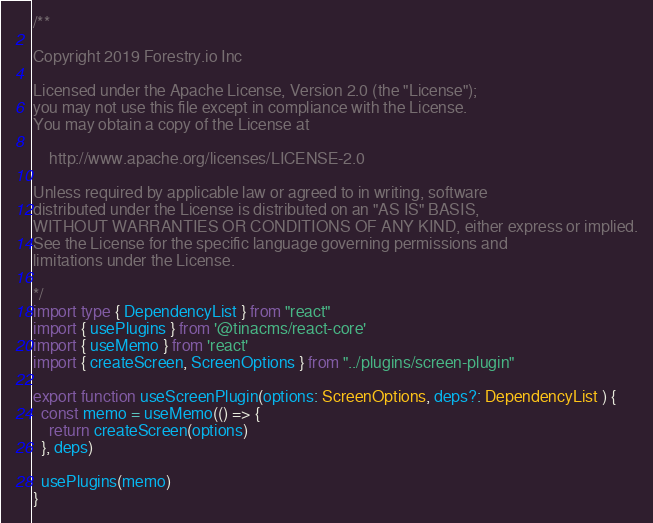<code> <loc_0><loc_0><loc_500><loc_500><_TypeScript_>/**

Copyright 2019 Forestry.io Inc

Licensed under the Apache License, Version 2.0 (the "License");
you may not use this file except in compliance with the License.
You may obtain a copy of the License at

    http://www.apache.org/licenses/LICENSE-2.0

Unless required by applicable law or agreed to in writing, software
distributed under the License is distributed on an "AS IS" BASIS,
WITHOUT WARRANTIES OR CONDITIONS OF ANY KIND, either express or implied.
See the License for the specific language governing permissions and
limitations under the License.

*/
import type { DependencyList } from "react"
import { usePlugins } from '@tinacms/react-core'
import { useMemo } from 'react'
import { createScreen, ScreenOptions } from "../plugins/screen-plugin"

export function useScreenPlugin(options: ScreenOptions, deps?: DependencyList ) {
  const memo = useMemo(() => {
    return createScreen(options)
  }, deps)

  usePlugins(memo)
}
</code> 